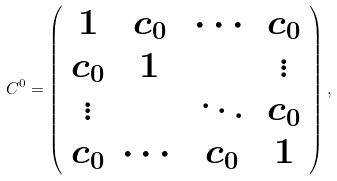<formula> <loc_0><loc_0><loc_500><loc_500>C ^ { 0 } = \left ( \begin{array} { c c c c } 1 & c _ { 0 } & \cdots & c _ { 0 } \\ c _ { 0 } & 1 & & \vdots \\ \vdots & & \ddots & c _ { 0 } \\ c _ { 0 } & \cdots & c _ { 0 } & 1 \end{array} \right ) ,</formula> 